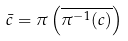Convert formula to latex. <formula><loc_0><loc_0><loc_500><loc_500>\bar { c } = \pi \left ( \overline { \pi ^ { - 1 } ( c ) } \right )</formula> 